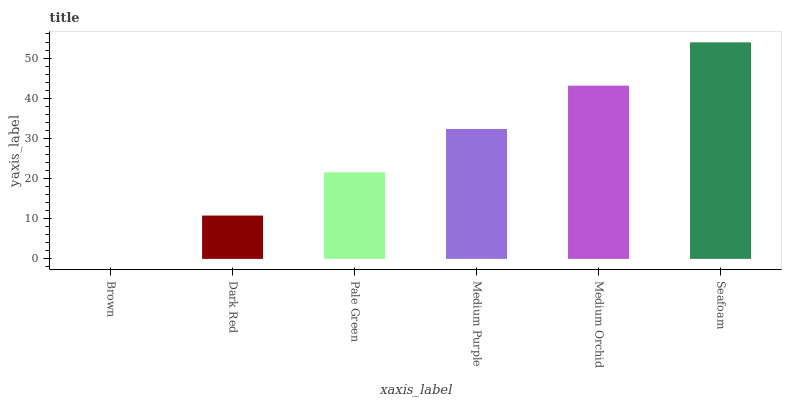Is Brown the minimum?
Answer yes or no. Yes. Is Seafoam the maximum?
Answer yes or no. Yes. Is Dark Red the minimum?
Answer yes or no. No. Is Dark Red the maximum?
Answer yes or no. No. Is Dark Red greater than Brown?
Answer yes or no. Yes. Is Brown less than Dark Red?
Answer yes or no. Yes. Is Brown greater than Dark Red?
Answer yes or no. No. Is Dark Red less than Brown?
Answer yes or no. No. Is Medium Purple the high median?
Answer yes or no. Yes. Is Pale Green the low median?
Answer yes or no. Yes. Is Dark Red the high median?
Answer yes or no. No. Is Medium Purple the low median?
Answer yes or no. No. 